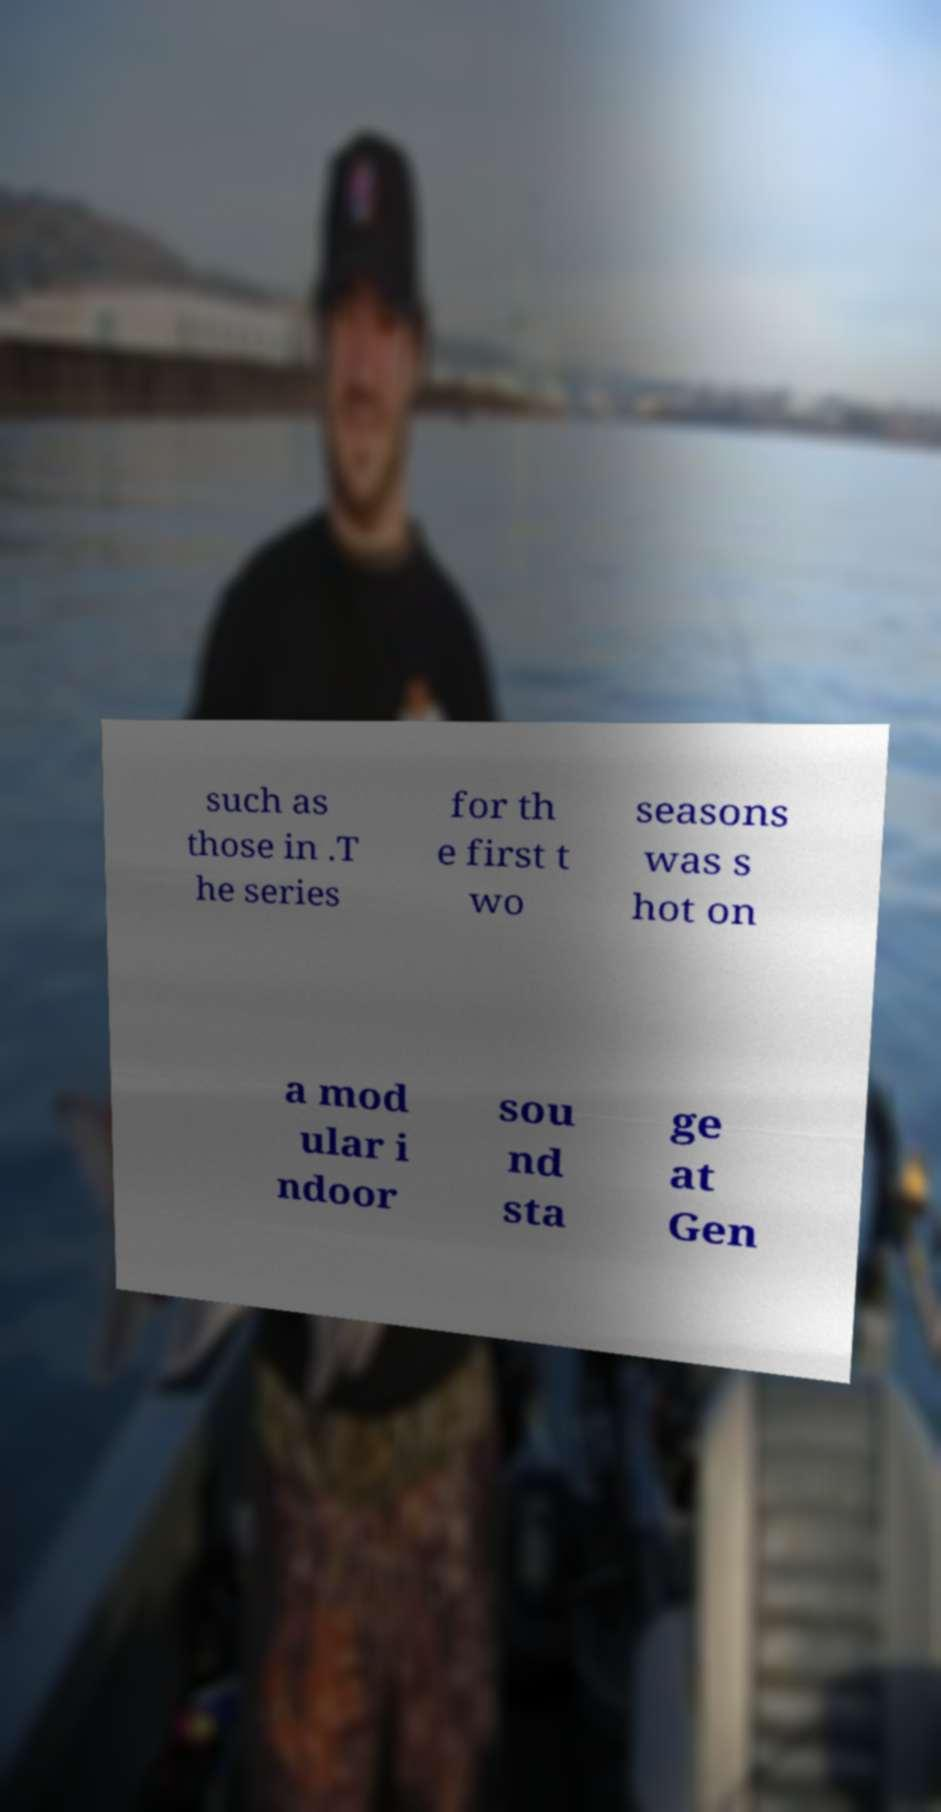There's text embedded in this image that I need extracted. Can you transcribe it verbatim? such as those in .T he series for th e first t wo seasons was s hot on a mod ular i ndoor sou nd sta ge at Gen 